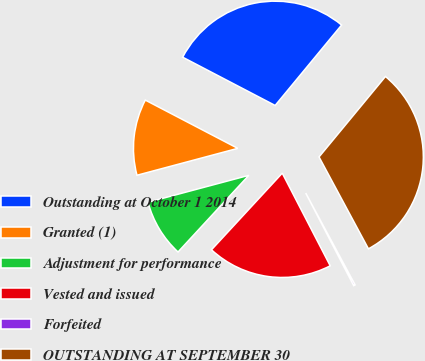Convert chart. <chart><loc_0><loc_0><loc_500><loc_500><pie_chart><fcel>Outstanding at October 1 2014<fcel>Granted (1)<fcel>Adjustment for performance<fcel>Vested and issued<fcel>Forfeited<fcel>OUTSTANDING AT SEPTEMBER 30<nl><fcel>28.33%<fcel>11.81%<fcel>8.98%<fcel>19.47%<fcel>0.25%<fcel>31.16%<nl></chart> 